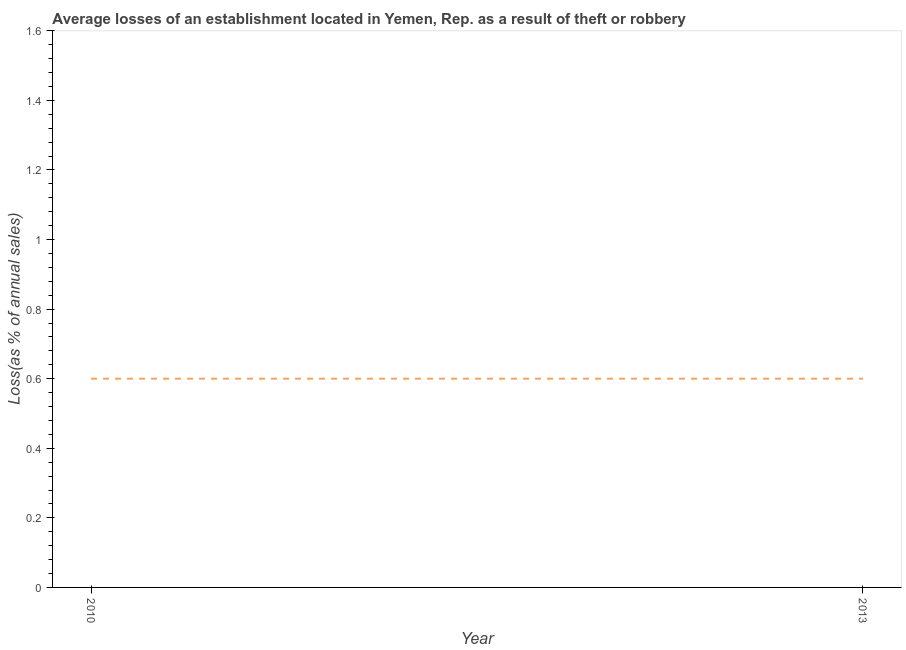What is the losses due to theft in 2013?
Provide a short and direct response. 0.6. In which year was the losses due to theft minimum?
Give a very brief answer. 2010. What is the sum of the losses due to theft?
Your response must be concise. 1.2. What is the average losses due to theft per year?
Provide a succinct answer. 0.6. Do a majority of the years between 2013 and 2010 (inclusive) have losses due to theft greater than 0.32 %?
Keep it short and to the point. No. In how many years, is the losses due to theft greater than the average losses due to theft taken over all years?
Offer a terse response. 0. Does the losses due to theft monotonically increase over the years?
Provide a short and direct response. No. How many lines are there?
Provide a succinct answer. 1. How many years are there in the graph?
Give a very brief answer. 2. Does the graph contain any zero values?
Your answer should be compact. No. What is the title of the graph?
Keep it short and to the point. Average losses of an establishment located in Yemen, Rep. as a result of theft or robbery. What is the label or title of the Y-axis?
Give a very brief answer. Loss(as % of annual sales). What is the Loss(as % of annual sales) of 2010?
Keep it short and to the point. 0.6. What is the ratio of the Loss(as % of annual sales) in 2010 to that in 2013?
Your answer should be very brief. 1. 